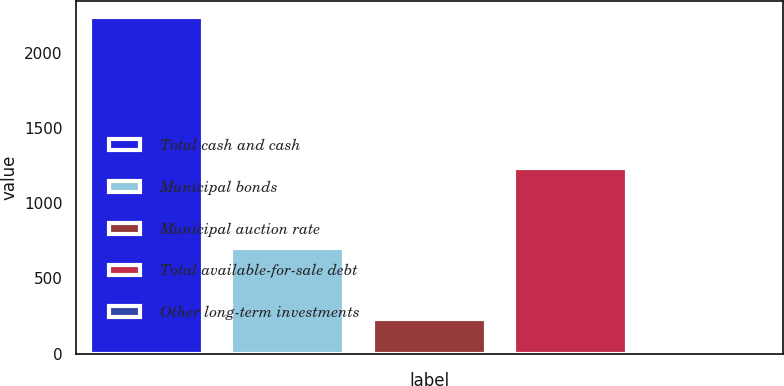Convert chart to OTSL. <chart><loc_0><loc_0><loc_500><loc_500><bar_chart><fcel>Total cash and cash<fcel>Municipal bonds<fcel>Municipal auction rate<fcel>Total available-for-sale debt<fcel>Other long-term investments<nl><fcel>2234<fcel>701<fcel>232.4<fcel>1230<fcel>10<nl></chart> 